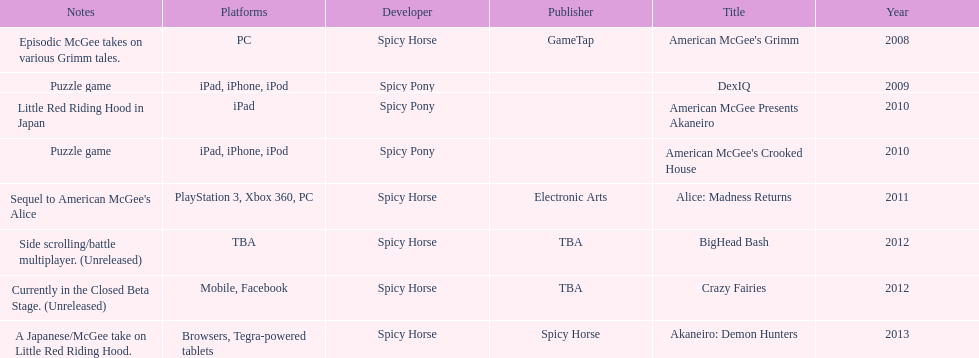How many platforms did american mcgee's grimm run on? 1. 